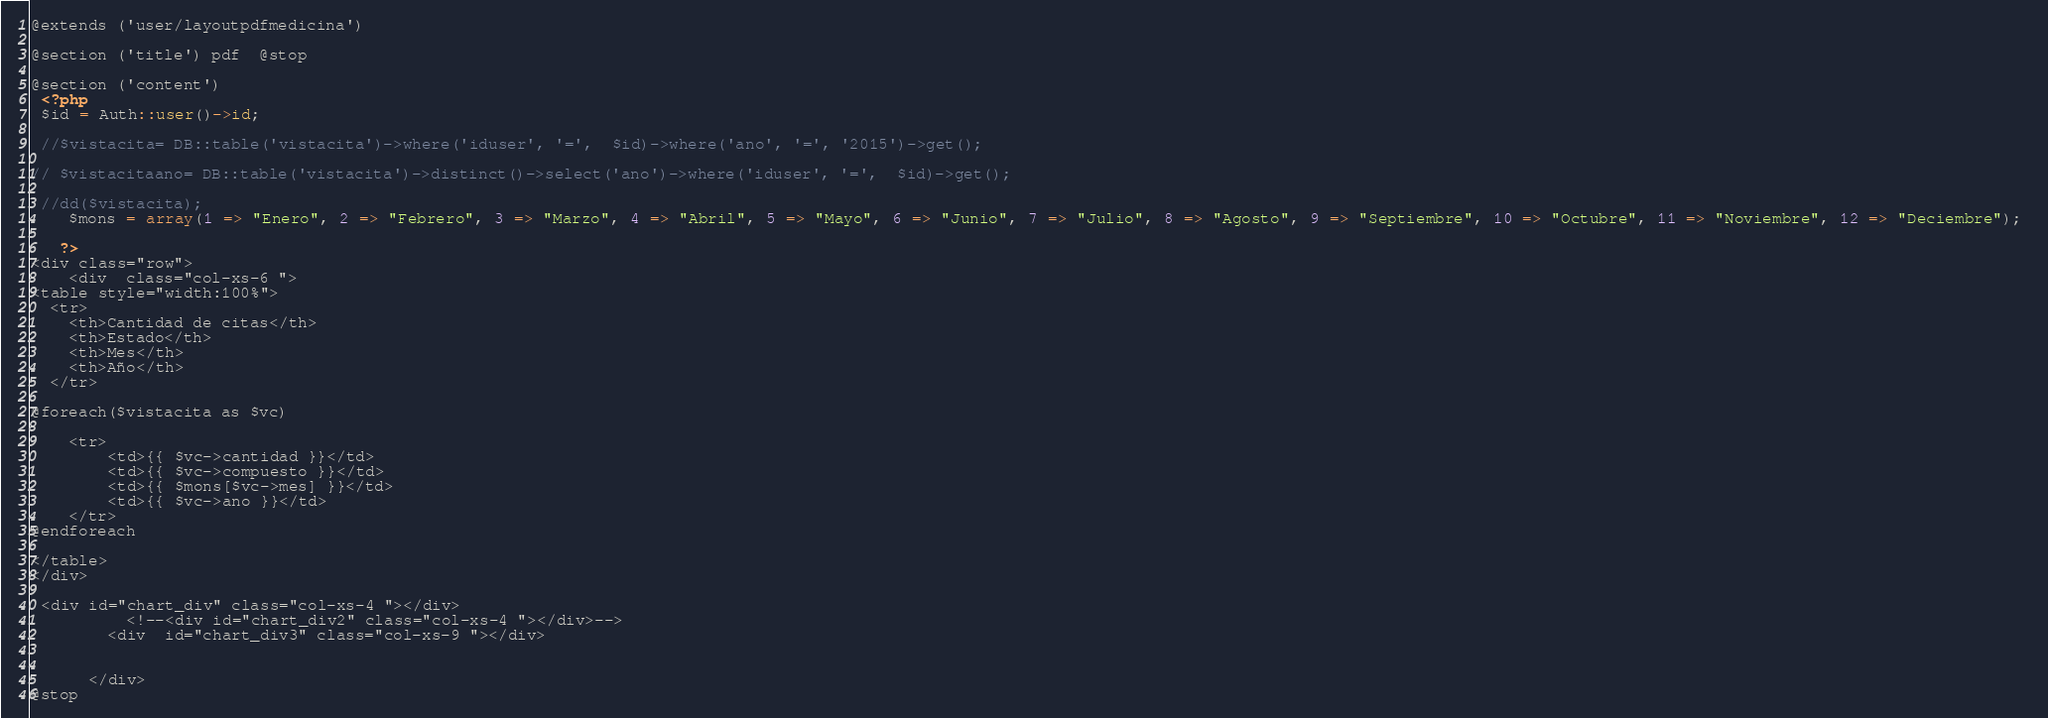<code> <loc_0><loc_0><loc_500><loc_500><_PHP_>@extends ('user/layoutpdfmedicina')

@section ('title') pdf  @stop

@section ('content')
 <?php 
 $id = Auth::user()->id;
	
 //$vistacita= DB::table('vistacita')->where('iduser', '=',  $id)->where('ano', '=', '2015')->get();

// $vistacitaano= DB::table('vistacita')->distinct()->select('ano')->where('iduser', '=',  $id)->get();

 //dd($vistacita);
	$mons = array(1 => "Enero", 2 => "Febrero", 3 => "Marzo", 4 => "Abril", 5 => "Mayo", 6 => "Junio", 7 => "Julio", 8 => "Agosto", 9 => "Septiembre", 10 => "Octubre", 11 => "Noviembre", 12 => "Deciembre"); 
 
   ?>
<div class="row">
	<div  class="col-xs-6 ">
<table style="width:100%">
  <tr>
  	<th>Cantidad de citas</th>
  	<th>Estado</th> 
    <th>Mes</th> 
    <th>Año</th>
  </tr>

@foreach($vistacita as $vc)

	<tr>
	    <td>{{ $vc->cantidad }}</td>
	    <td>{{ $vc->compuesto }}</td> 
	    <td>{{ $mons[$vc->mes] }}</td> 
	    <td>{{ $vc->ano }}</td>
  	</tr>
@endforeach

</table>
</div>

 <div id="chart_div" class="col-xs-4 "></div>
          <!--<div id="chart_div2" class="col-xs-4 "></div>-->
        <div  id="chart_div3" class="col-xs-9 "></div>
        
      
      </div>
@stop</code> 